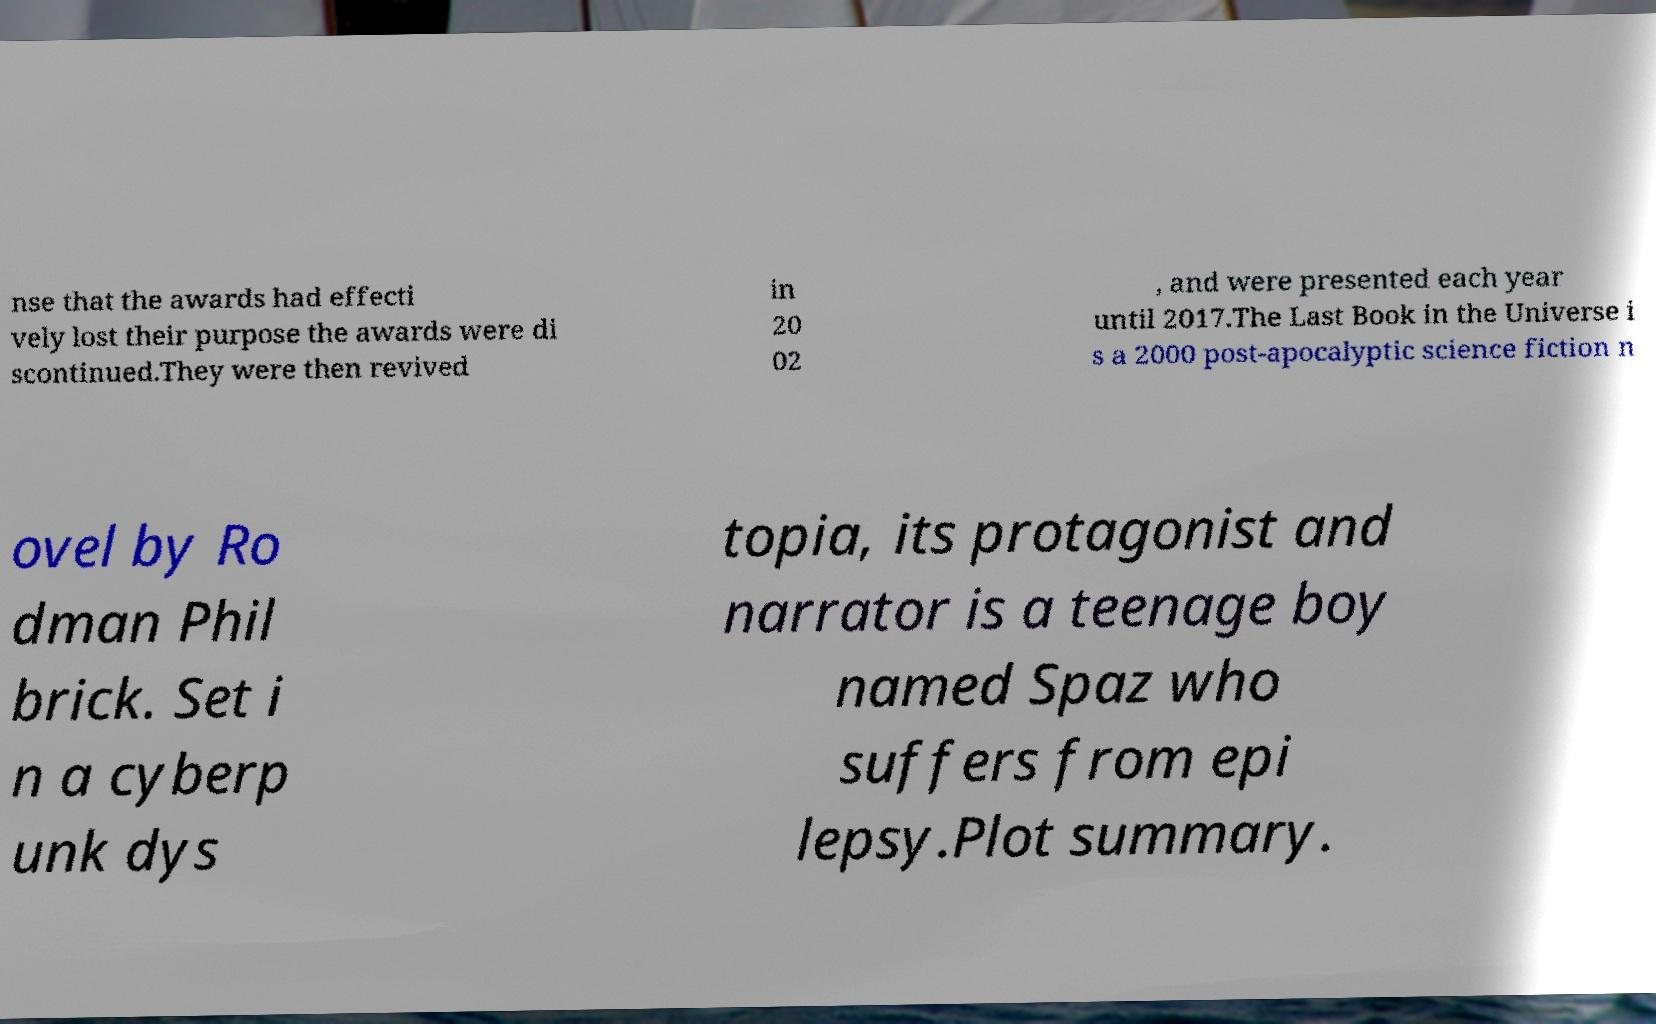Could you assist in decoding the text presented in this image and type it out clearly? nse that the awards had effecti vely lost their purpose the awards were di scontinued.They were then revived in 20 02 , and were presented each year until 2017.The Last Book in the Universe i s a 2000 post-apocalyptic science fiction n ovel by Ro dman Phil brick. Set i n a cyberp unk dys topia, its protagonist and narrator is a teenage boy named Spaz who suffers from epi lepsy.Plot summary. 